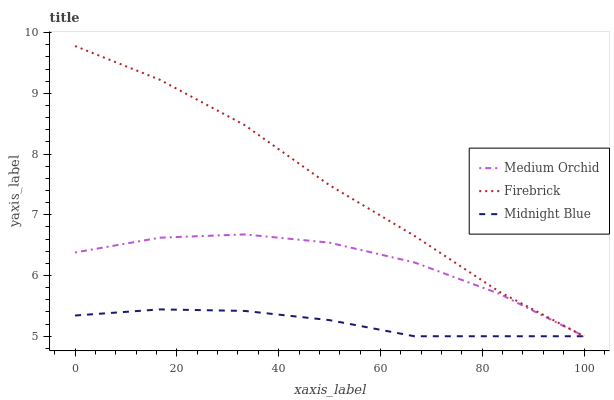Does Midnight Blue have the minimum area under the curve?
Answer yes or no. Yes. Does Firebrick have the maximum area under the curve?
Answer yes or no. Yes. Does Medium Orchid have the minimum area under the curve?
Answer yes or no. No. Does Medium Orchid have the maximum area under the curve?
Answer yes or no. No. Is Midnight Blue the smoothest?
Answer yes or no. Yes. Is Medium Orchid the roughest?
Answer yes or no. Yes. Is Medium Orchid the smoothest?
Answer yes or no. No. Is Midnight Blue the roughest?
Answer yes or no. No. Does Firebrick have the highest value?
Answer yes or no. Yes. Does Medium Orchid have the highest value?
Answer yes or no. No. Does Firebrick intersect Midnight Blue?
Answer yes or no. Yes. Is Firebrick less than Midnight Blue?
Answer yes or no. No. Is Firebrick greater than Midnight Blue?
Answer yes or no. No. 